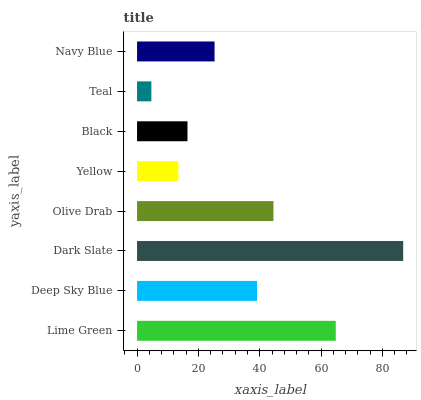Is Teal the minimum?
Answer yes or no. Yes. Is Dark Slate the maximum?
Answer yes or no. Yes. Is Deep Sky Blue the minimum?
Answer yes or no. No. Is Deep Sky Blue the maximum?
Answer yes or no. No. Is Lime Green greater than Deep Sky Blue?
Answer yes or no. Yes. Is Deep Sky Blue less than Lime Green?
Answer yes or no. Yes. Is Deep Sky Blue greater than Lime Green?
Answer yes or no. No. Is Lime Green less than Deep Sky Blue?
Answer yes or no. No. Is Deep Sky Blue the high median?
Answer yes or no. Yes. Is Navy Blue the low median?
Answer yes or no. Yes. Is Dark Slate the high median?
Answer yes or no. No. Is Lime Green the low median?
Answer yes or no. No. 